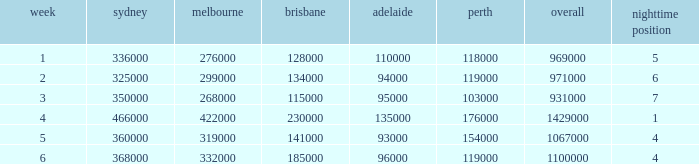What was the rating in Brisbane the week it was 276000 in Melbourne?  128000.0. 